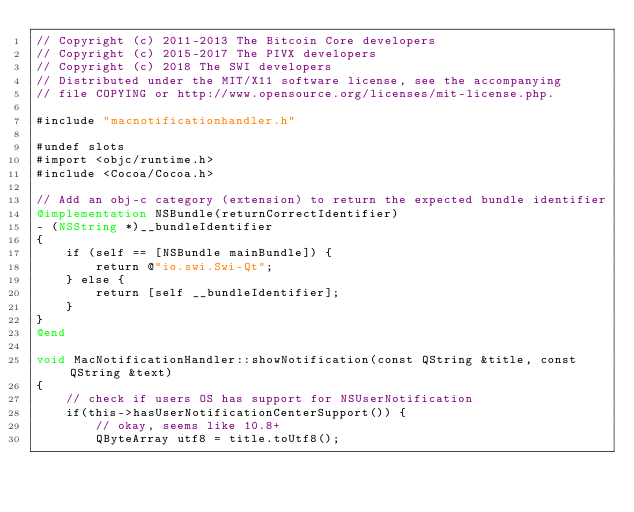<code> <loc_0><loc_0><loc_500><loc_500><_ObjectiveC_>// Copyright (c) 2011-2013 The Bitcoin Core developers
// Copyright (c) 2015-2017 The PIVX developers
// Copyright (c) 2018 The SWI developers
// Distributed under the MIT/X11 software license, see the accompanying
// file COPYING or http://www.opensource.org/licenses/mit-license.php.

#include "macnotificationhandler.h"

#undef slots
#import <objc/runtime.h>
#include <Cocoa/Cocoa.h>

// Add an obj-c category (extension) to return the expected bundle identifier
@implementation NSBundle(returnCorrectIdentifier)
- (NSString *)__bundleIdentifier
{
    if (self == [NSBundle mainBundle]) {
        return @"io.swi.Swi-Qt";
    } else {
        return [self __bundleIdentifier];
    }
}
@end

void MacNotificationHandler::showNotification(const QString &title, const QString &text)
{
    // check if users OS has support for NSUserNotification
    if(this->hasUserNotificationCenterSupport()) {
        // okay, seems like 10.8+
        QByteArray utf8 = title.toUtf8();</code> 